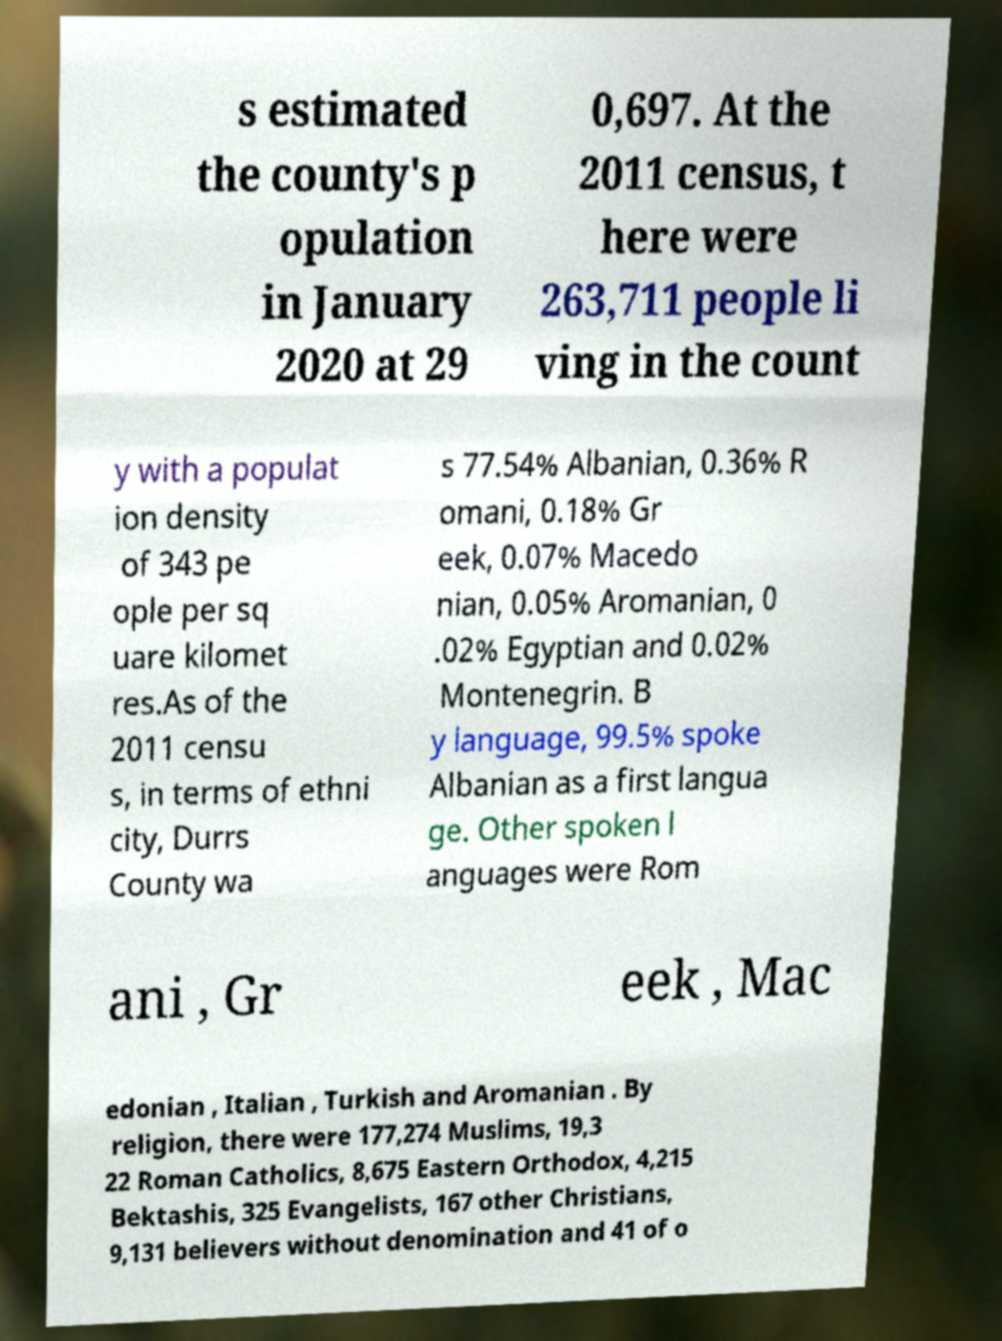Can you read and provide the text displayed in the image?This photo seems to have some interesting text. Can you extract and type it out for me? s estimated the county's p opulation in January 2020 at 29 0,697. At the 2011 census, t here were 263,711 people li ving in the count y with a populat ion density of 343 pe ople per sq uare kilomet res.As of the 2011 censu s, in terms of ethni city, Durrs County wa s 77.54% Albanian, 0.36% R omani, 0.18% Gr eek, 0.07% Macedo nian, 0.05% Aromanian, 0 .02% Egyptian and 0.02% Montenegrin. B y language, 99.5% spoke Albanian as a first langua ge. Other spoken l anguages were Rom ani , Gr eek , Mac edonian , Italian , Turkish and Aromanian . By religion, there were 177,274 Muslims, 19,3 22 Roman Catholics, 8,675 Eastern Orthodox, 4,215 Bektashis, 325 Evangelists, 167 other Christians, 9,131 believers without denomination and 41 of o 